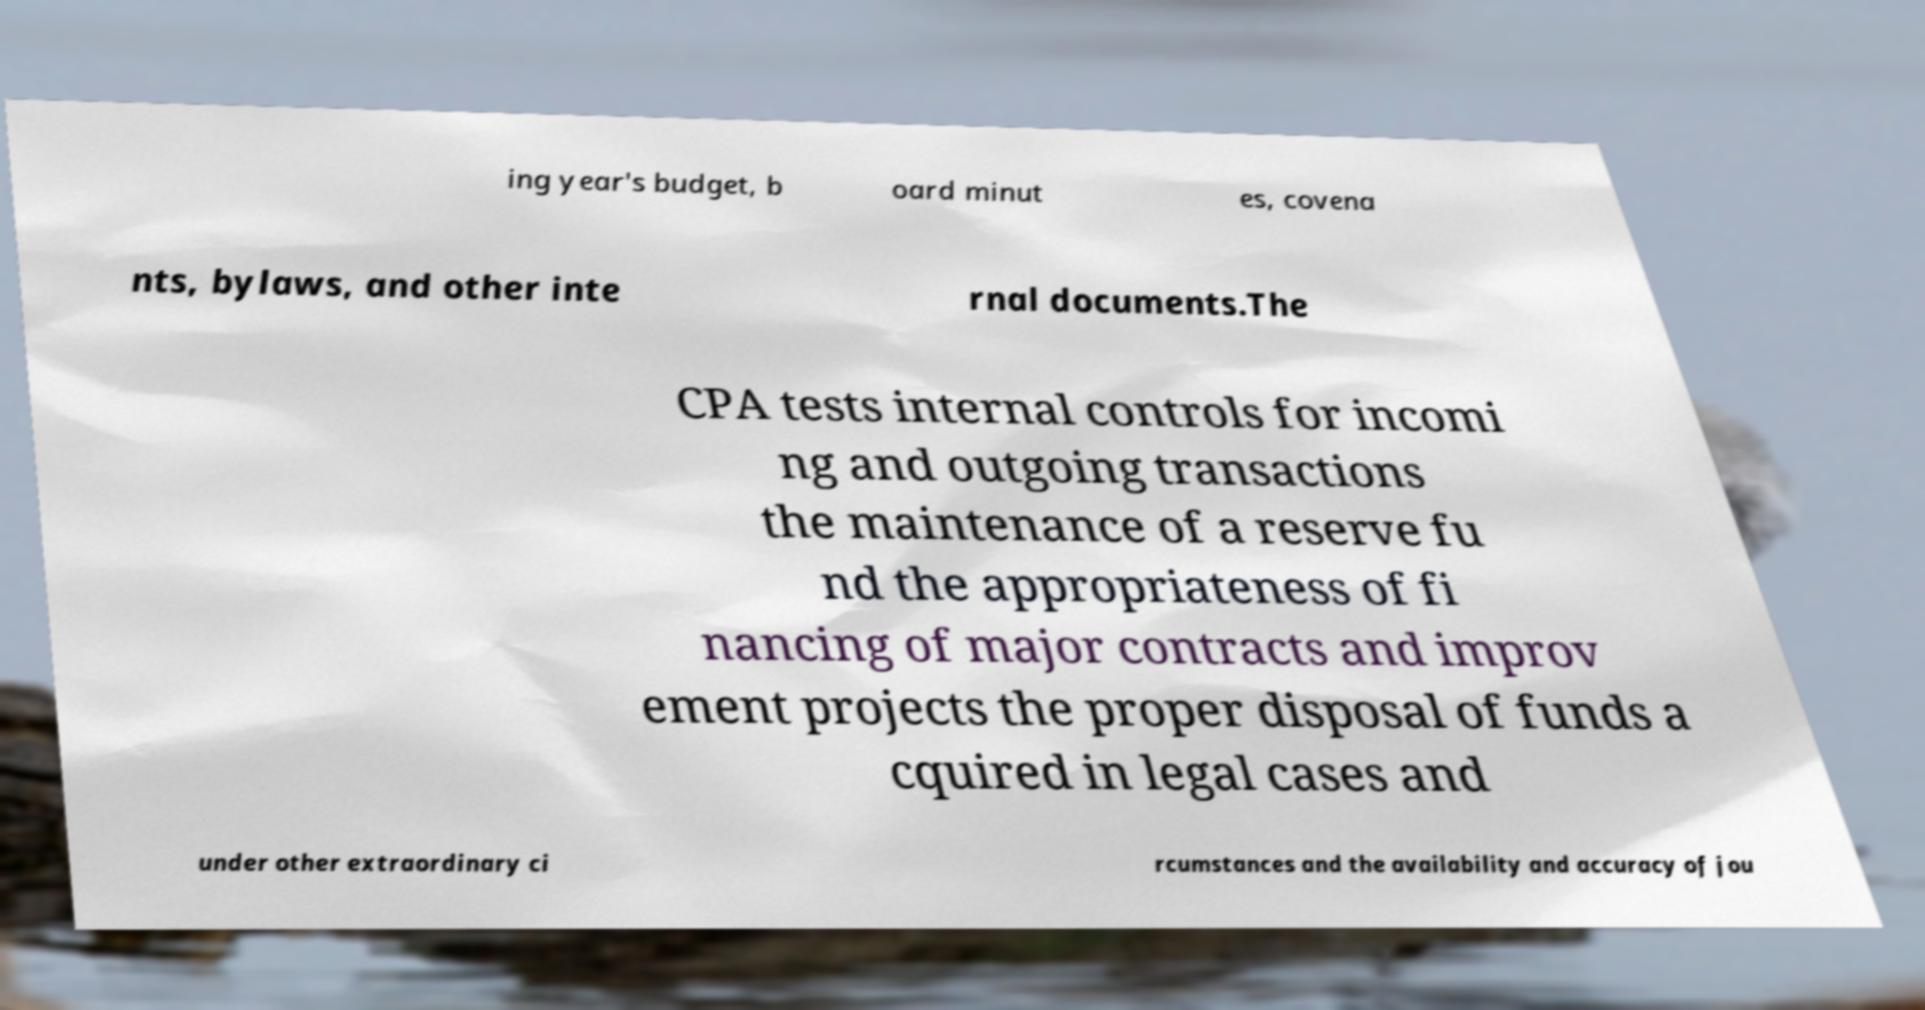What messages or text are displayed in this image? I need them in a readable, typed format. ing year's budget, b oard minut es, covena nts, bylaws, and other inte rnal documents.The CPA tests internal controls for incomi ng and outgoing transactions the maintenance of a reserve fu nd the appropriateness of fi nancing of major contracts and improv ement projects the proper disposal of funds a cquired in legal cases and under other extraordinary ci rcumstances and the availability and accuracy of jou 